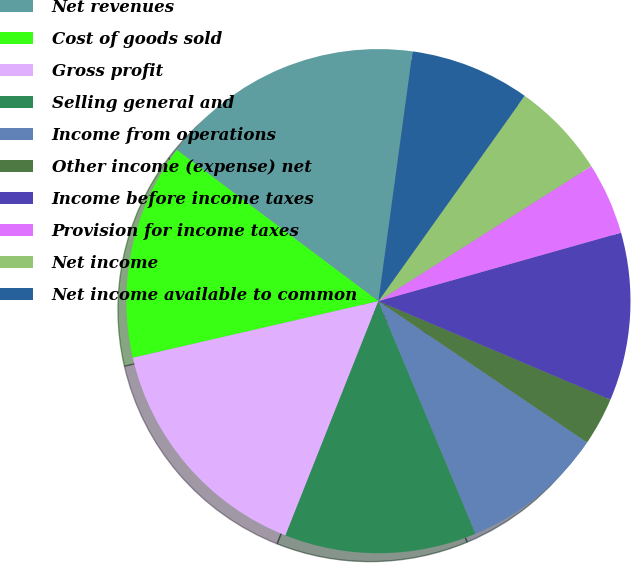Convert chart. <chart><loc_0><loc_0><loc_500><loc_500><pie_chart><fcel>Net revenues<fcel>Cost of goods sold<fcel>Gross profit<fcel>Selling general and<fcel>Income from operations<fcel>Other income (expense) net<fcel>Income before income taxes<fcel>Provision for income taxes<fcel>Net income<fcel>Net income available to common<nl><fcel>16.92%<fcel>13.85%<fcel>15.38%<fcel>12.31%<fcel>9.23%<fcel>3.08%<fcel>10.77%<fcel>4.62%<fcel>6.15%<fcel>7.69%<nl></chart> 